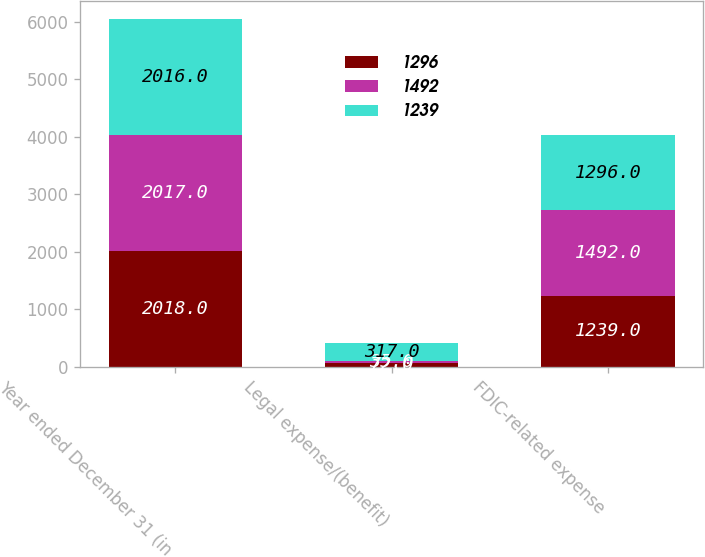Convert chart to OTSL. <chart><loc_0><loc_0><loc_500><loc_500><stacked_bar_chart><ecel><fcel>Year ended December 31 (in<fcel>Legal expense/(benefit)<fcel>FDIC-related expense<nl><fcel>1296<fcel>2018<fcel>72<fcel>1239<nl><fcel>1492<fcel>2017<fcel>35<fcel>1492<nl><fcel>1239<fcel>2016<fcel>317<fcel>1296<nl></chart> 